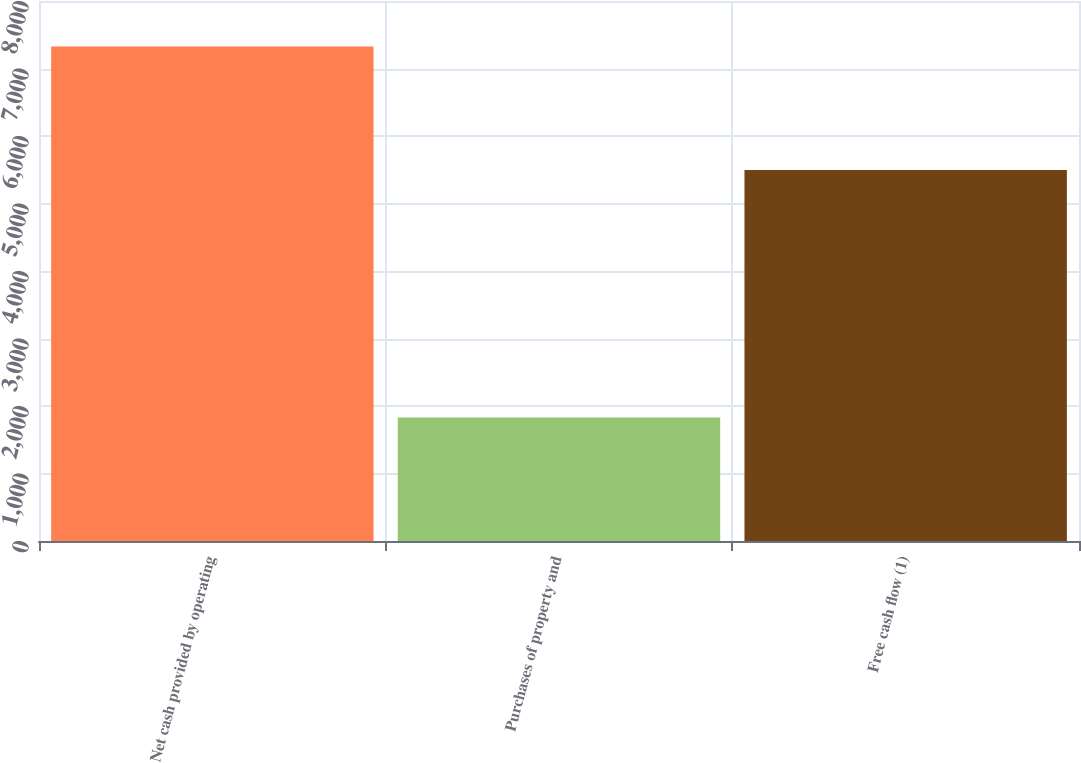Convert chart to OTSL. <chart><loc_0><loc_0><loc_500><loc_500><bar_chart><fcel>Net cash provided by operating<fcel>Purchases of property and<fcel>Free cash flow (1)<nl><fcel>7326<fcel>1831<fcel>5495<nl></chart> 